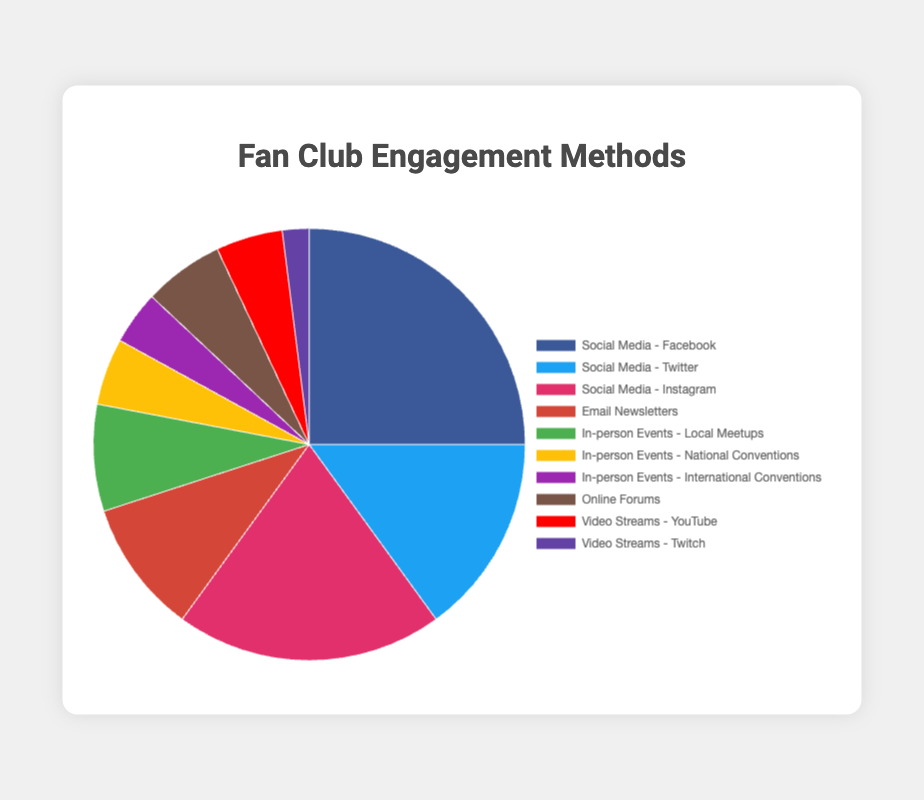what is the most popular engagement method among fan club members? The most popular engagement method is the one with the highest percentage on the pie chart. The method labeled "Social Media - Facebook" has the highest value at 25%.
Answer: Social Media - Facebook Which method has a higher engagement rate, Social Media - Instagram or Social Media - Twitter? Compare the percentages for “Social Media - Instagram” and “Social Media - Twitter” shown on the pie chart. Instagram has 20%, whereas Twitter has 15%.
Answer: Social Media - Instagram What is the total percentage of in-person events? Sum the percentages of all in-person events: Local Meetups (8%) + National Conventions (5%) + International Conventions (4%). This equals 17%.
Answer: 17% How much more popular are email newsletters compared to video streams on Twitch? Look at the percentages for "Email Newsletters" and "Video Streams - Twitch" and subtract the latter from the former: 10% - 2% = 8%.
Answer: 8% Which engagement method makes up the smallest percentage? Identify the method with the smallest value in the pie chart. "Video Streams - Twitch" has the smallest percentage at 2%.
Answer: Video Streams - Twitch How does the engagement rate of online forums compare to that of video streams on YouTube? From the pie chart, "Online Forums" are at 6% and "Video Streams - YouTube" are at 5%. Since 6% is larger than 5%, Online Forums have a higher engagement rate.
Answer: Online Forums What is the combined percentage of all social media methods? Add the percentages for all social media methods: Facebook (25%) + Twitter (15%) + Instagram (20%) = 60%.
Answer: 60% Which video streaming method is more popular: YouTube or Twitch? Compare their respective percentages shown in the pie chart. YouTube is 5%, while Twitch is 2%.
Answer: YouTube Are Email Newsletters more popular than all in-person events combined? First, find the total percentage of in-person events: Local Meetups (8%) + National Conventions (5%) + International Conventions (4%) = 17%. Compare this with "Email Newsletters" at 10%. Since 17% is greater than 10%, in-person events combined are more popular.
Answer: No What percentage of engagement methods are non-social media methods? Calculate the total percentage of non-social media methods: Email Newsletters (10%) + Local Meetups (8%) + National Conventions (5%) + International Conventions (4%) + Online Forums (6%) + YouTube (5%) + Twitch (2%) = 40%.
Answer: 40% 